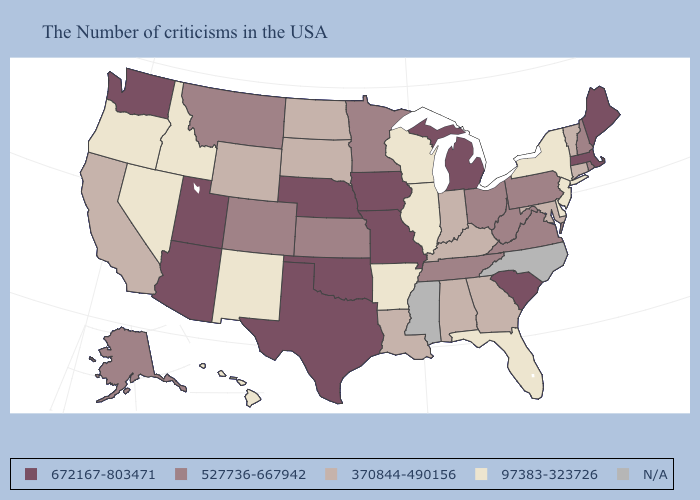What is the value of Massachusetts?
Short answer required. 672167-803471. What is the highest value in the Northeast ?
Give a very brief answer. 672167-803471. Among the states that border Tennessee , does Arkansas have the lowest value?
Short answer required. Yes. Name the states that have a value in the range 97383-323726?
Write a very short answer. New York, New Jersey, Delaware, Florida, Wisconsin, Illinois, Arkansas, New Mexico, Idaho, Nevada, Oregon, Hawaii. Name the states that have a value in the range 97383-323726?
Be succinct. New York, New Jersey, Delaware, Florida, Wisconsin, Illinois, Arkansas, New Mexico, Idaho, Nevada, Oregon, Hawaii. What is the value of California?
Keep it brief. 370844-490156. Does Texas have the highest value in the USA?
Answer briefly. Yes. How many symbols are there in the legend?
Give a very brief answer. 5. Does the first symbol in the legend represent the smallest category?
Give a very brief answer. No. What is the value of Oregon?
Answer briefly. 97383-323726. Name the states that have a value in the range N/A?
Concise answer only. North Carolina, Mississippi. Name the states that have a value in the range 370844-490156?
Write a very short answer. Vermont, Connecticut, Maryland, Georgia, Kentucky, Indiana, Alabama, Louisiana, South Dakota, North Dakota, Wyoming, California. 